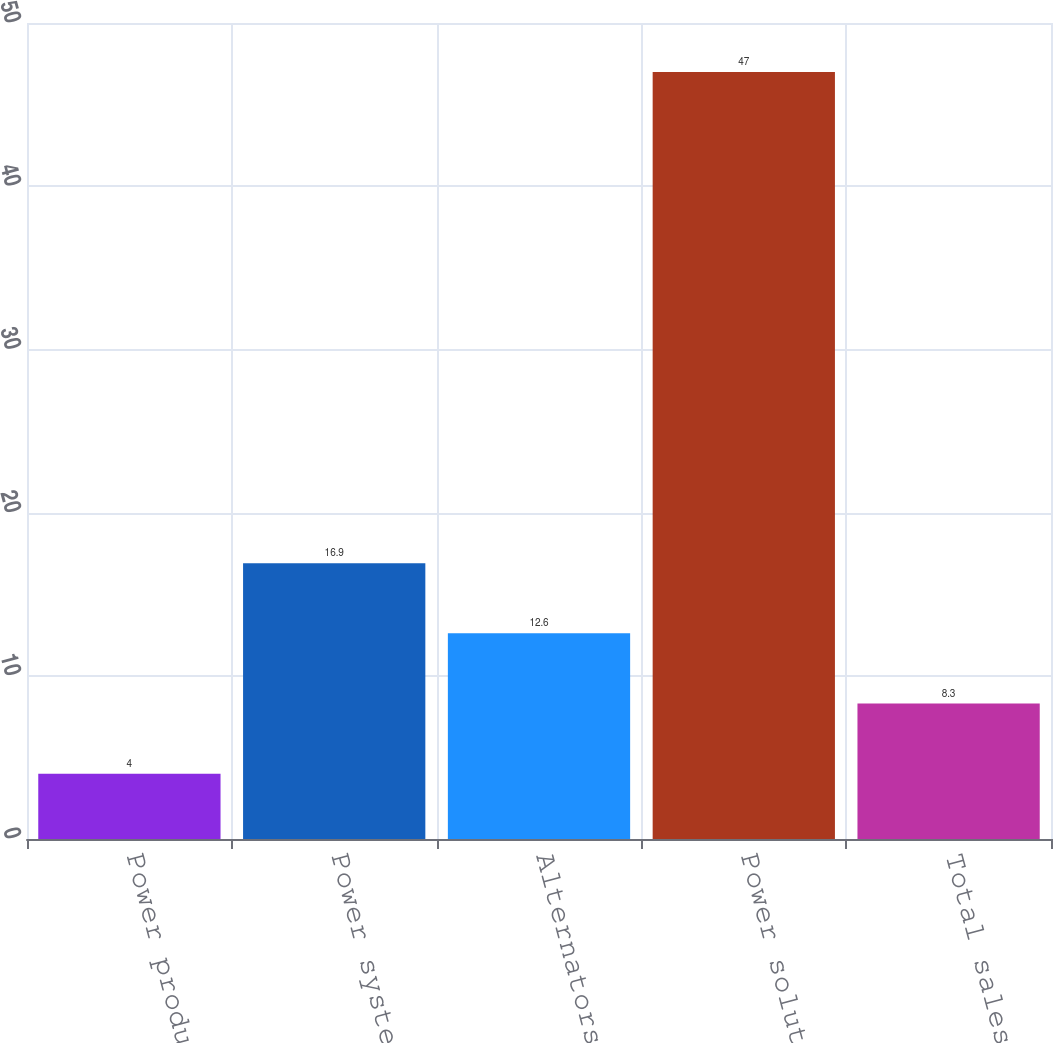Convert chart. <chart><loc_0><loc_0><loc_500><loc_500><bar_chart><fcel>Power products<fcel>Power systems<fcel>Alternators<fcel>Power solutions<fcel>Total sales<nl><fcel>4<fcel>16.9<fcel>12.6<fcel>47<fcel>8.3<nl></chart> 